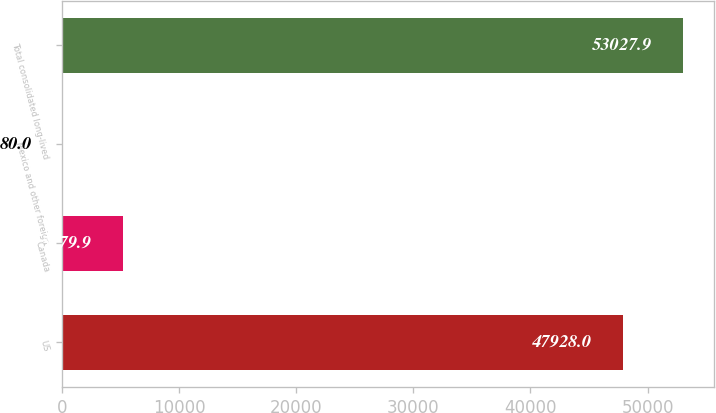Convert chart to OTSL. <chart><loc_0><loc_0><loc_500><loc_500><bar_chart><fcel>US<fcel>Canada<fcel>Mexico and other foreign<fcel>Total consolidated long-lived<nl><fcel>47928<fcel>5179.9<fcel>80<fcel>53027.9<nl></chart> 